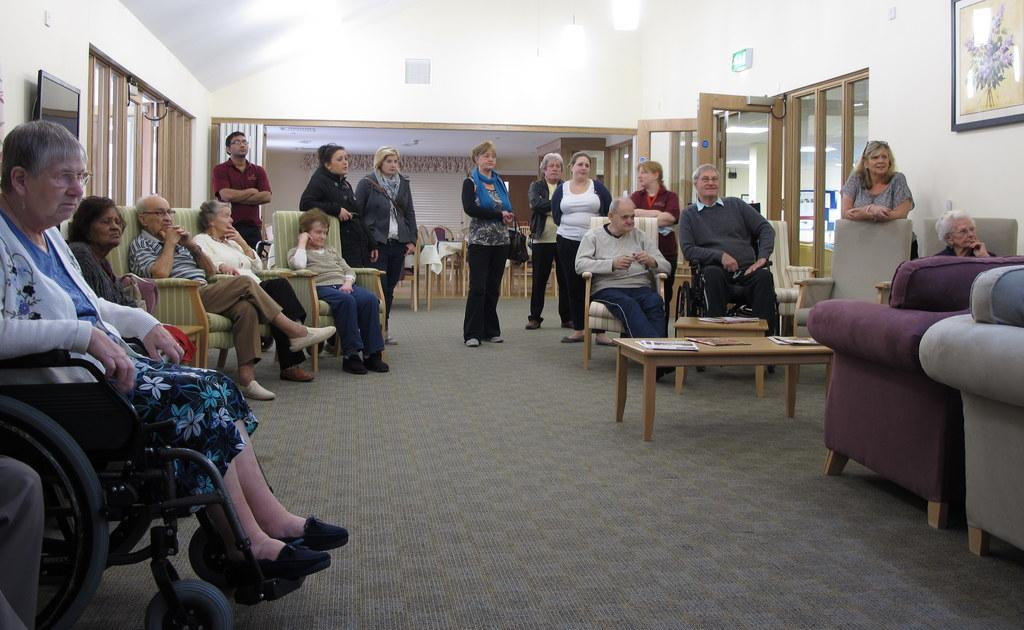What is the primary subject of the image? The primary subject of the image is people. What are some of the people in the image doing? Some people are sitting on chairs, while others are standing in the background. What type of fruit is being used to plot a scheme in the image? There is no fruit or plotting of schemes present in the image; it simply features people sitting and standing. 